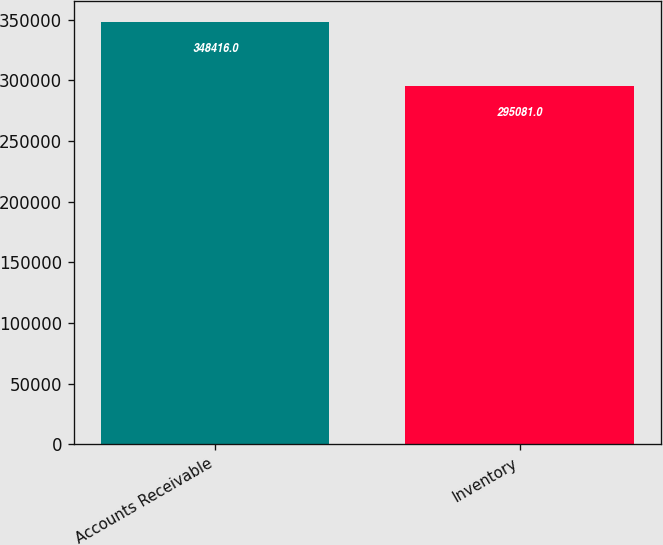Convert chart to OTSL. <chart><loc_0><loc_0><loc_500><loc_500><bar_chart><fcel>Accounts Receivable<fcel>Inventory<nl><fcel>348416<fcel>295081<nl></chart> 